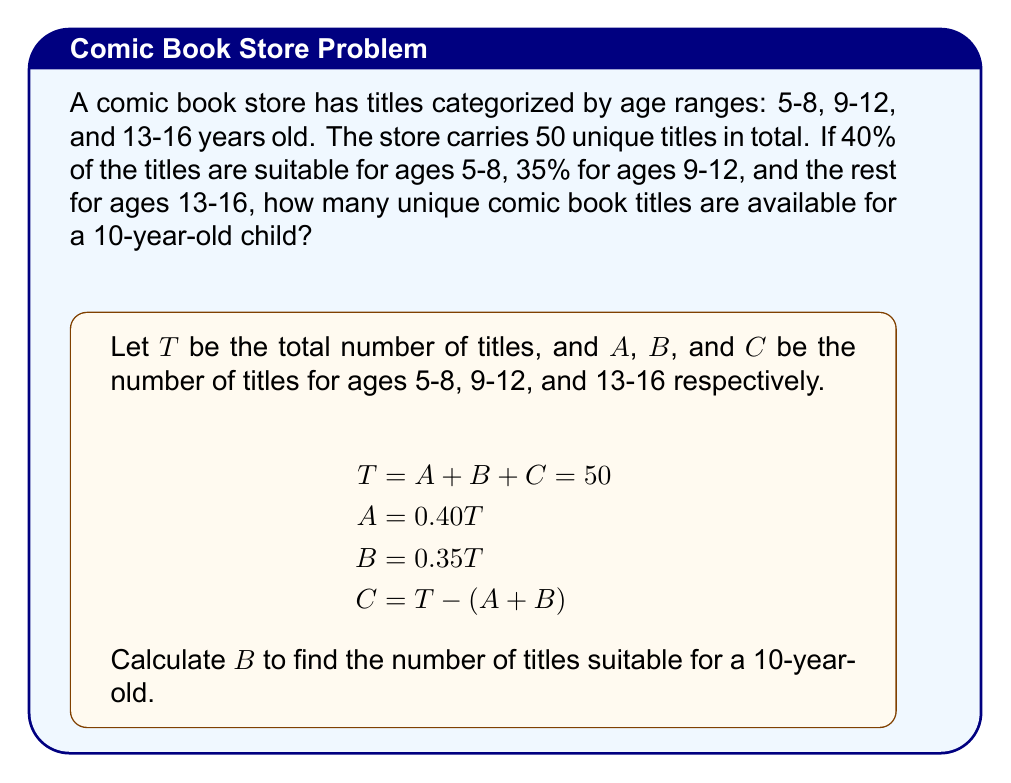Solve this math problem. Let's solve this problem step by step:

1) We know that the total number of titles, $T = 50$.

2) For ages 5-8 (group A):
   $A = 0.40T = 0.40 \times 50 = 20$ titles

3) For ages 9-12 (group B):
   $B = 0.35T = 0.35 \times 50 = 17.5$ titles
   Since we can't have half a comic book, we round down to 17 titles.

4) For ages 13-16 (group C):
   $C = T - (A + B) = 50 - (20 + 17) = 13$ titles

5) A 10-year-old child falls into the 9-12 age range, so they would be interested in the titles from group B.

Therefore, there are 17 unique comic book titles available for a 10-year-old child.
Answer: 17 titles 